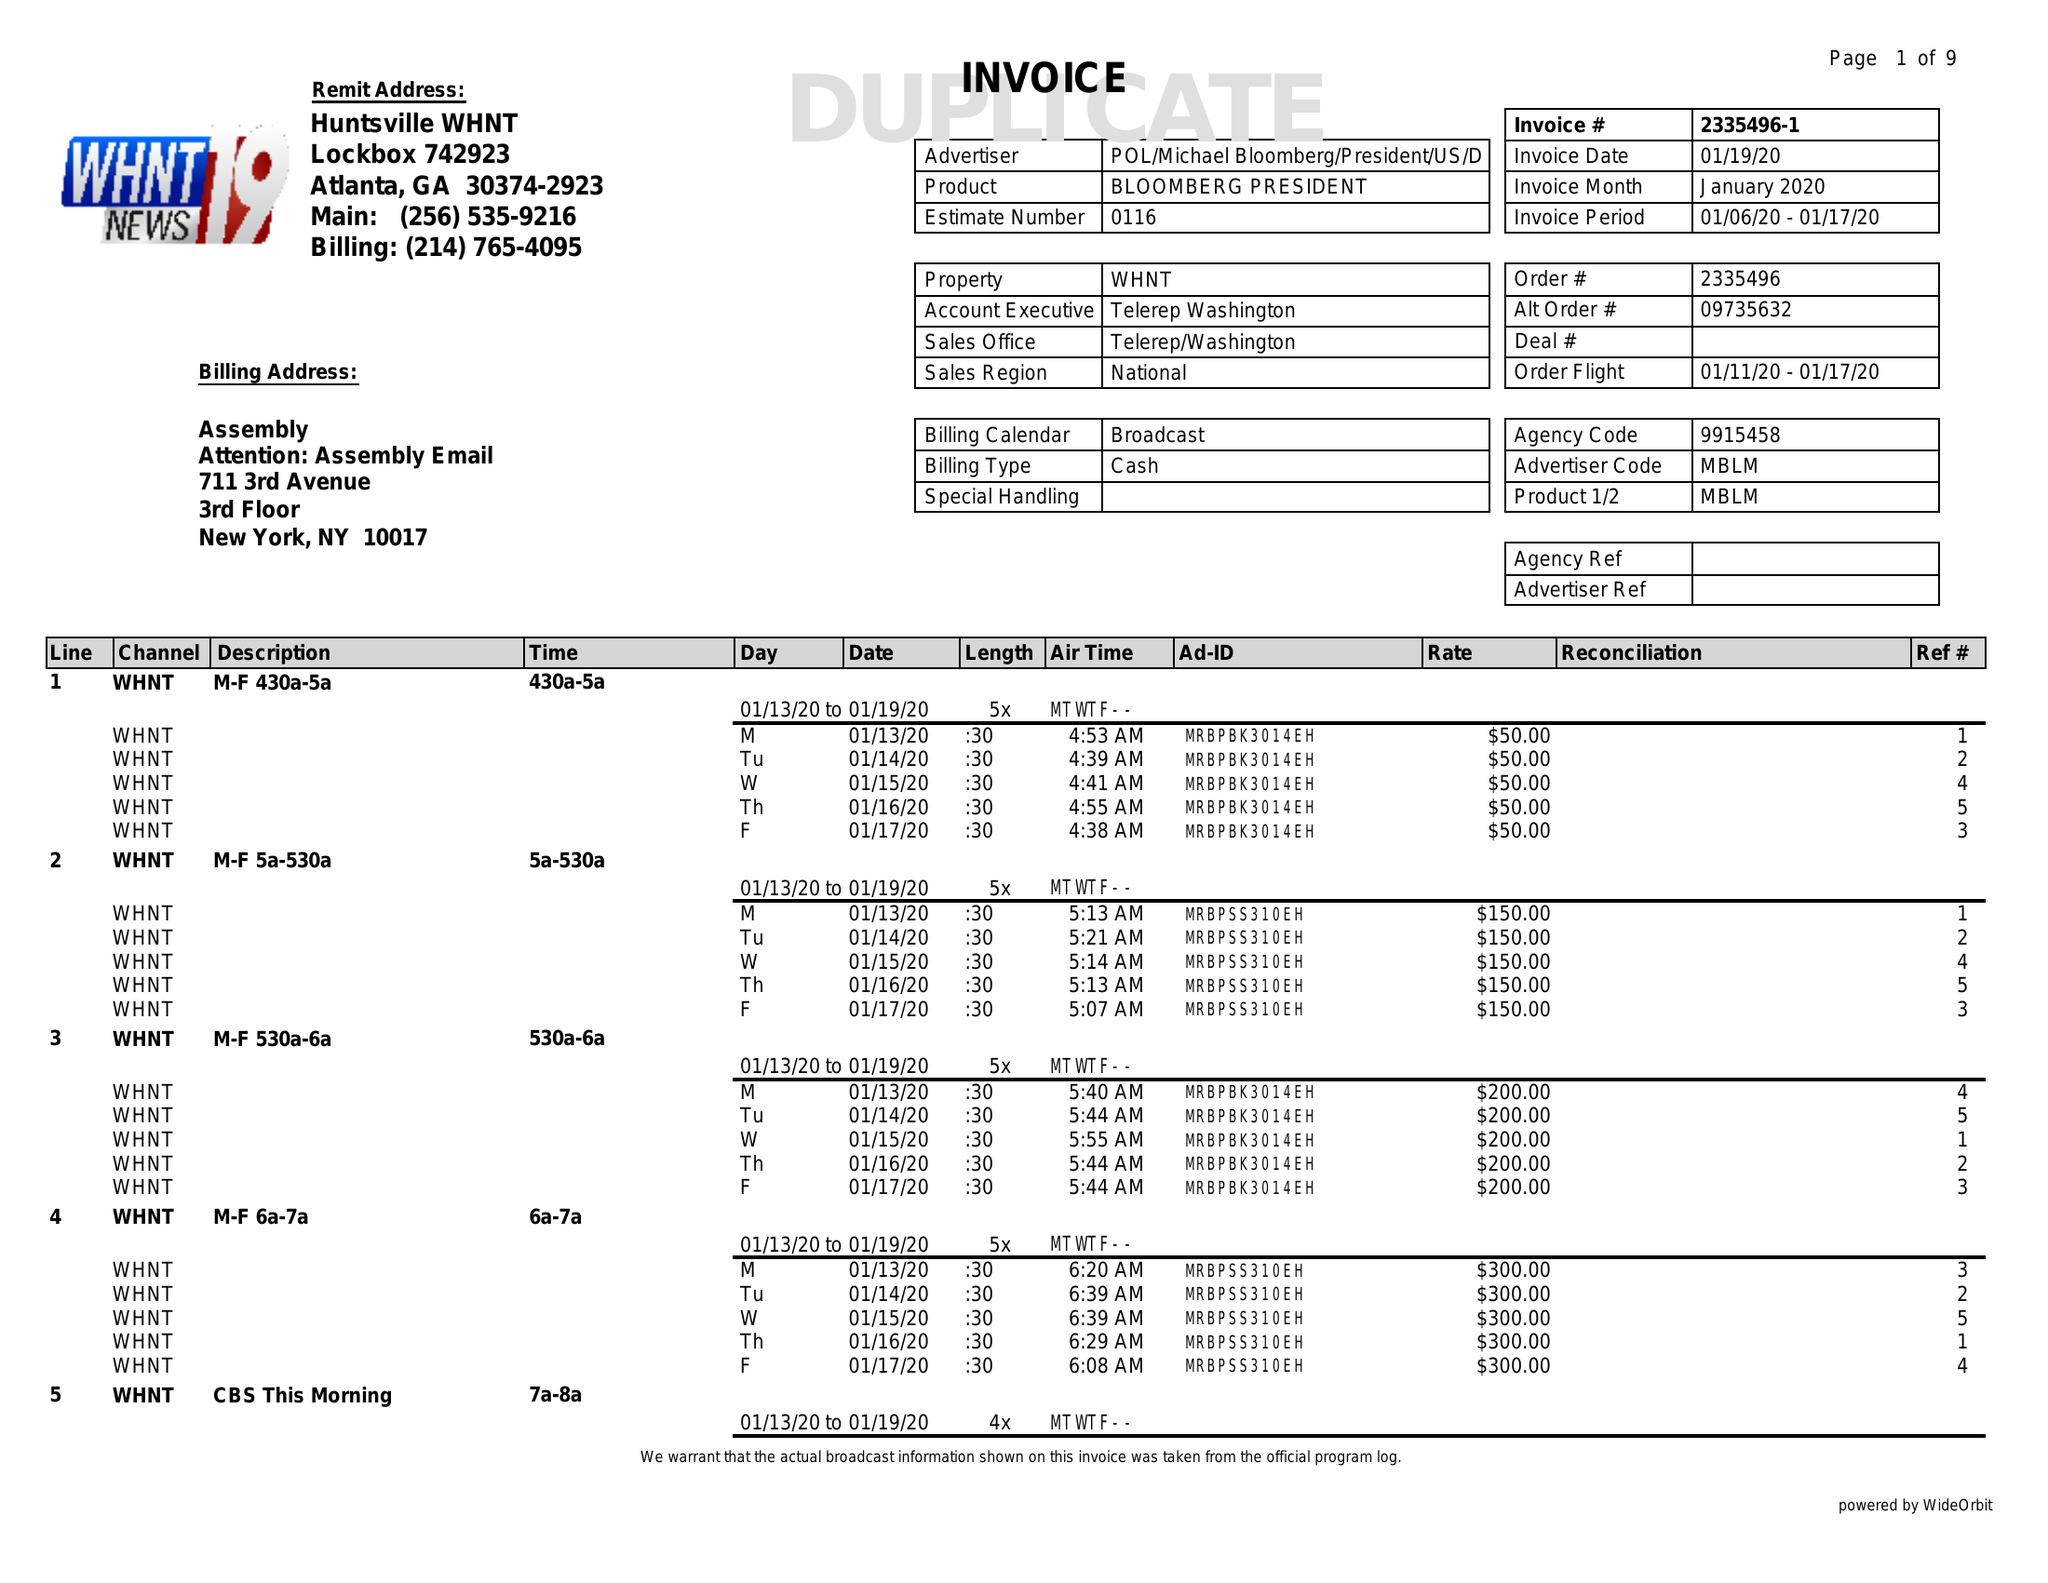What is the value for the flight_from?
Answer the question using a single word or phrase. 01/11/20 